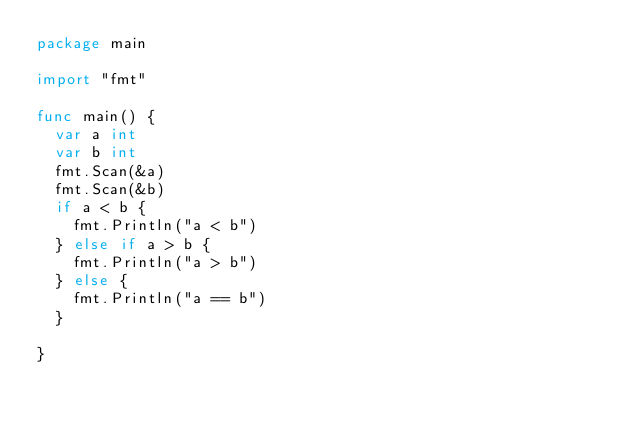<code> <loc_0><loc_0><loc_500><loc_500><_Go_>package main

import "fmt"

func main() {
	var a int
	var b int
	fmt.Scan(&a)
	fmt.Scan(&b)
	if a < b {
		fmt.Println("a < b")
	} else if a > b {
		fmt.Println("a > b")
	} else {
		fmt.Println("a == b")
	}

}

</code> 